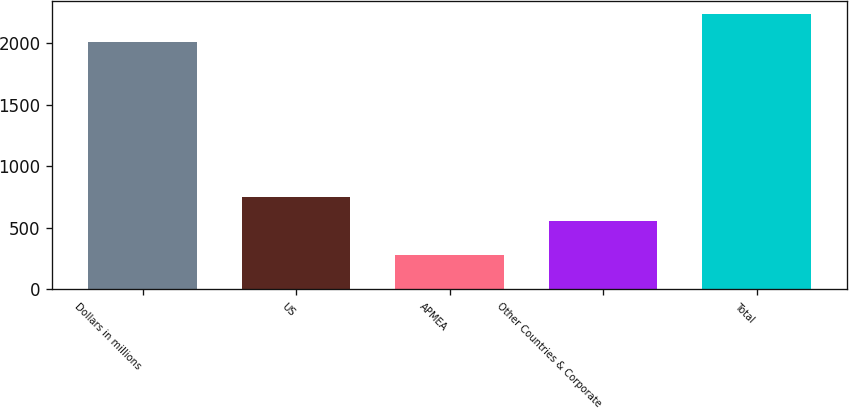Convert chart to OTSL. <chart><loc_0><loc_0><loc_500><loc_500><bar_chart><fcel>Dollars in millions<fcel>US<fcel>APMEA<fcel>Other Countries & Corporate<fcel>Total<nl><fcel>2009<fcel>751<fcel>276<fcel>552<fcel>2234<nl></chart> 